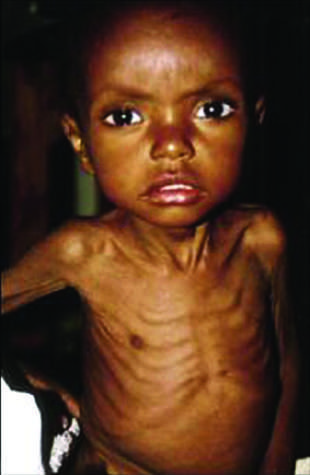does genomic dna appear to be too large for the emaciated body?
Answer the question using a single word or phrase. No 